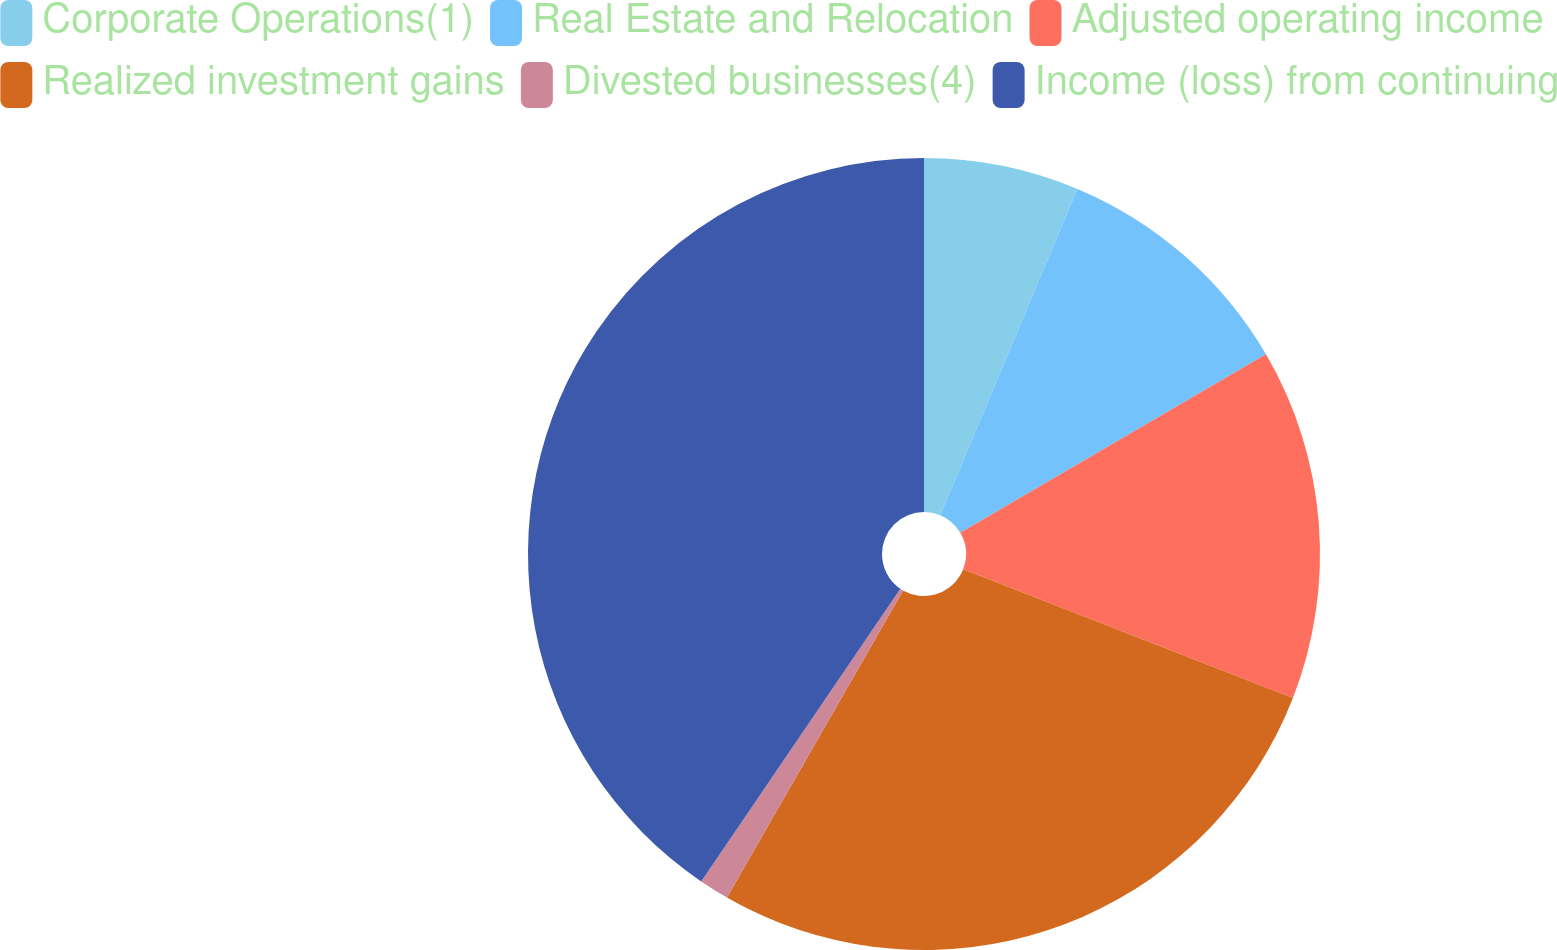Convert chart to OTSL. <chart><loc_0><loc_0><loc_500><loc_500><pie_chart><fcel>Corporate Operations(1)<fcel>Real Estate and Relocation<fcel>Adjusted operating income<fcel>Realized investment gains<fcel>Divested businesses(4)<fcel>Income (loss) from continuing<nl><fcel>6.33%<fcel>10.26%<fcel>14.33%<fcel>27.37%<fcel>1.22%<fcel>40.49%<nl></chart> 